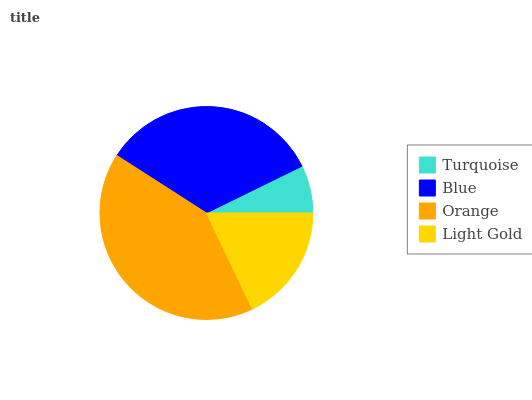Is Turquoise the minimum?
Answer yes or no. Yes. Is Orange the maximum?
Answer yes or no. Yes. Is Blue the minimum?
Answer yes or no. No. Is Blue the maximum?
Answer yes or no. No. Is Blue greater than Turquoise?
Answer yes or no. Yes. Is Turquoise less than Blue?
Answer yes or no. Yes. Is Turquoise greater than Blue?
Answer yes or no. No. Is Blue less than Turquoise?
Answer yes or no. No. Is Blue the high median?
Answer yes or no. Yes. Is Light Gold the low median?
Answer yes or no. Yes. Is Orange the high median?
Answer yes or no. No. Is Orange the low median?
Answer yes or no. No. 